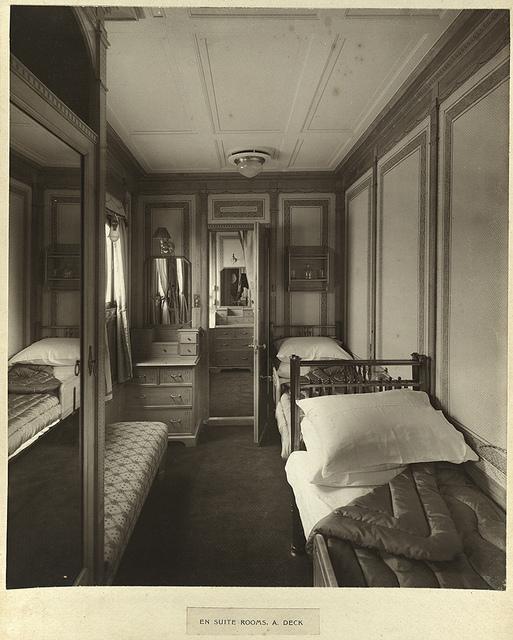How many beds are visible?
Give a very brief answer. 4. 